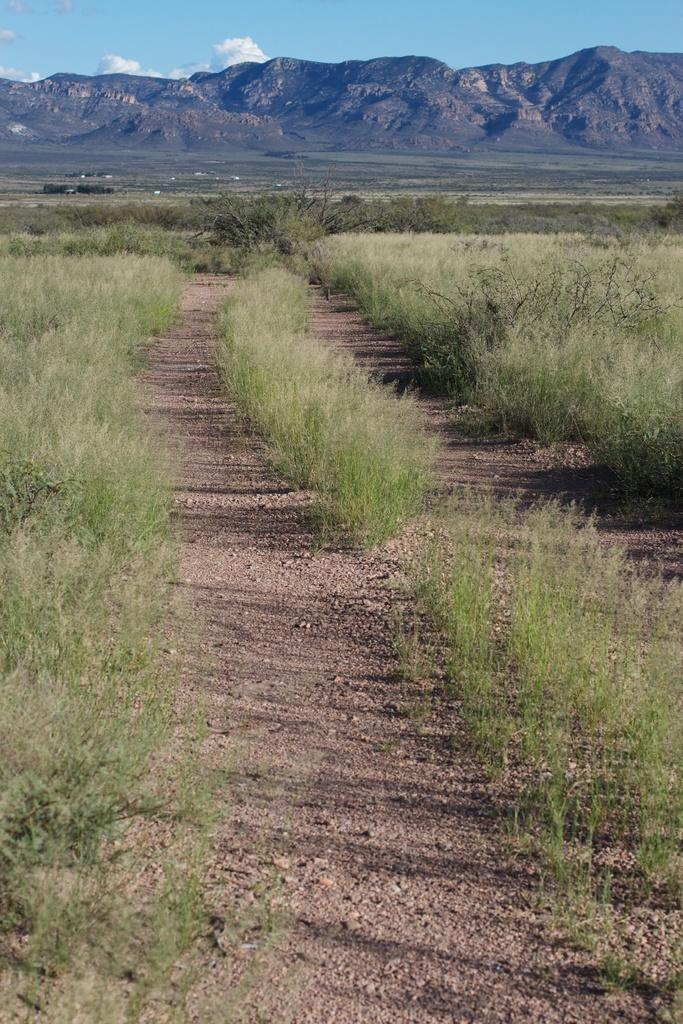What type of vegetation can be seen in the image? There are small plants and bushes in the image. What can be seen in the distance in the image? There are hills visible in the background of the image. What is visible in the sky in the image? There are clouds in the sky in the image. Can you see a sail in the image? There is no sail present in the image. Is this image a work of fiction? The image itself is not fiction, but it could be a part of a fictional story or setting. 